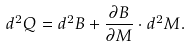<formula> <loc_0><loc_0><loc_500><loc_500>d ^ { 2 } Q = d ^ { 2 } B + \frac { \partial { B } } { \partial { M } } \cdot d ^ { 2 } M .</formula> 